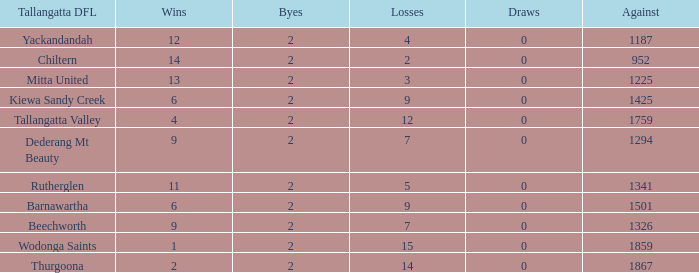What are the draws when wins are fwewer than 9 and byes fewer than 2? 0.0. 